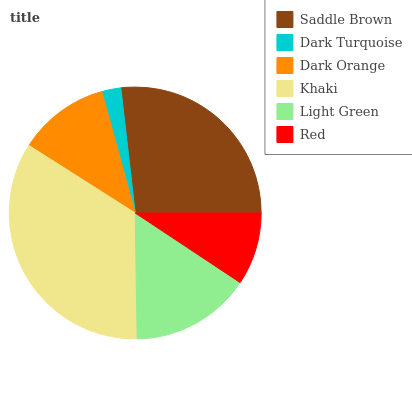Is Dark Turquoise the minimum?
Answer yes or no. Yes. Is Khaki the maximum?
Answer yes or no. Yes. Is Dark Orange the minimum?
Answer yes or no. No. Is Dark Orange the maximum?
Answer yes or no. No. Is Dark Orange greater than Dark Turquoise?
Answer yes or no. Yes. Is Dark Turquoise less than Dark Orange?
Answer yes or no. Yes. Is Dark Turquoise greater than Dark Orange?
Answer yes or no. No. Is Dark Orange less than Dark Turquoise?
Answer yes or no. No. Is Light Green the high median?
Answer yes or no. Yes. Is Dark Orange the low median?
Answer yes or no. Yes. Is Dark Orange the high median?
Answer yes or no. No. Is Saddle Brown the low median?
Answer yes or no. No. 